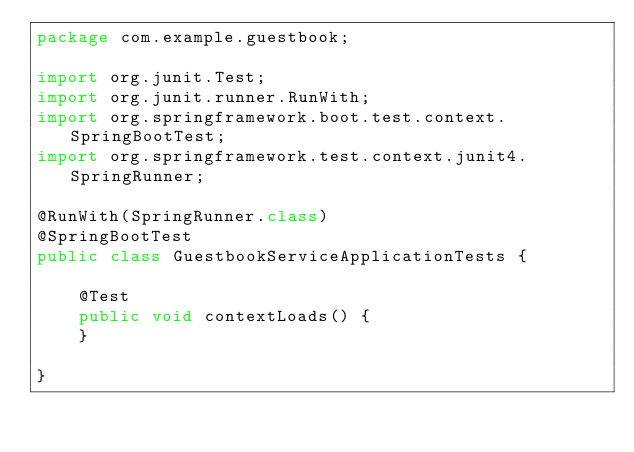Convert code to text. <code><loc_0><loc_0><loc_500><loc_500><_Java_>package com.example.guestbook;

import org.junit.Test;
import org.junit.runner.RunWith;
import org.springframework.boot.test.context.SpringBootTest;
import org.springframework.test.context.junit4.SpringRunner;

@RunWith(SpringRunner.class)
@SpringBootTest
public class GuestbookServiceApplicationTests {

	@Test
	public void contextLoads() {
	}

}
</code> 